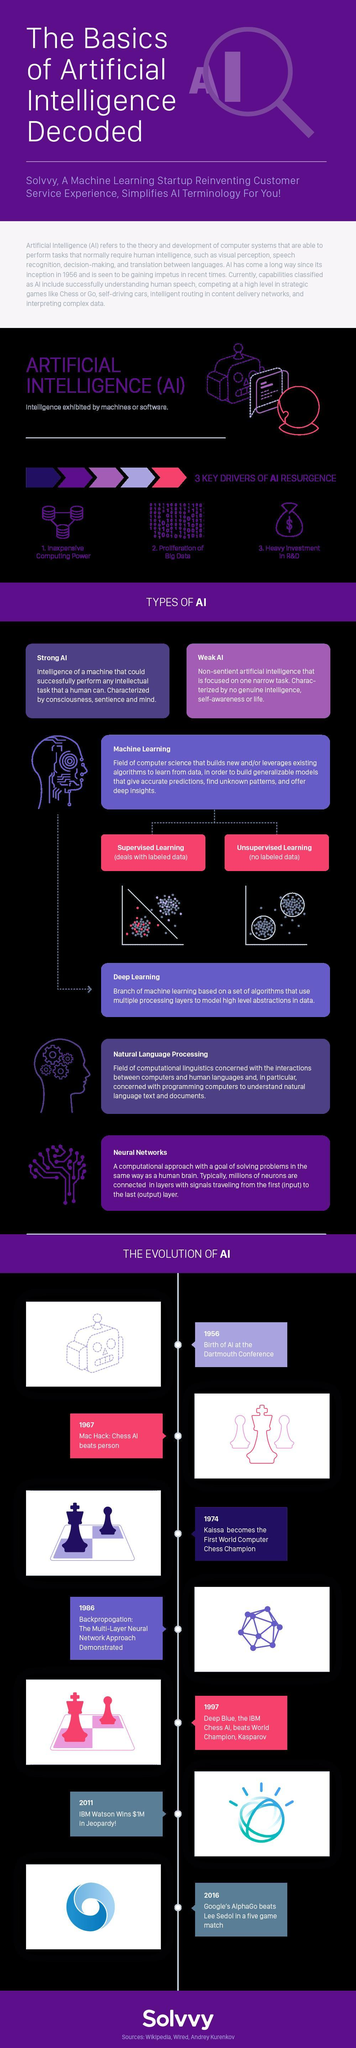Which all are the key drivers of AI Resurgence?
Answer the question with a short phrase. Inexpensive computing power, Proliferation of Big Data, Heavy Investment in R&D How many types of machine learning mentioned in this infographic? 2 How many types of AI mentioned in this infographic? 2 